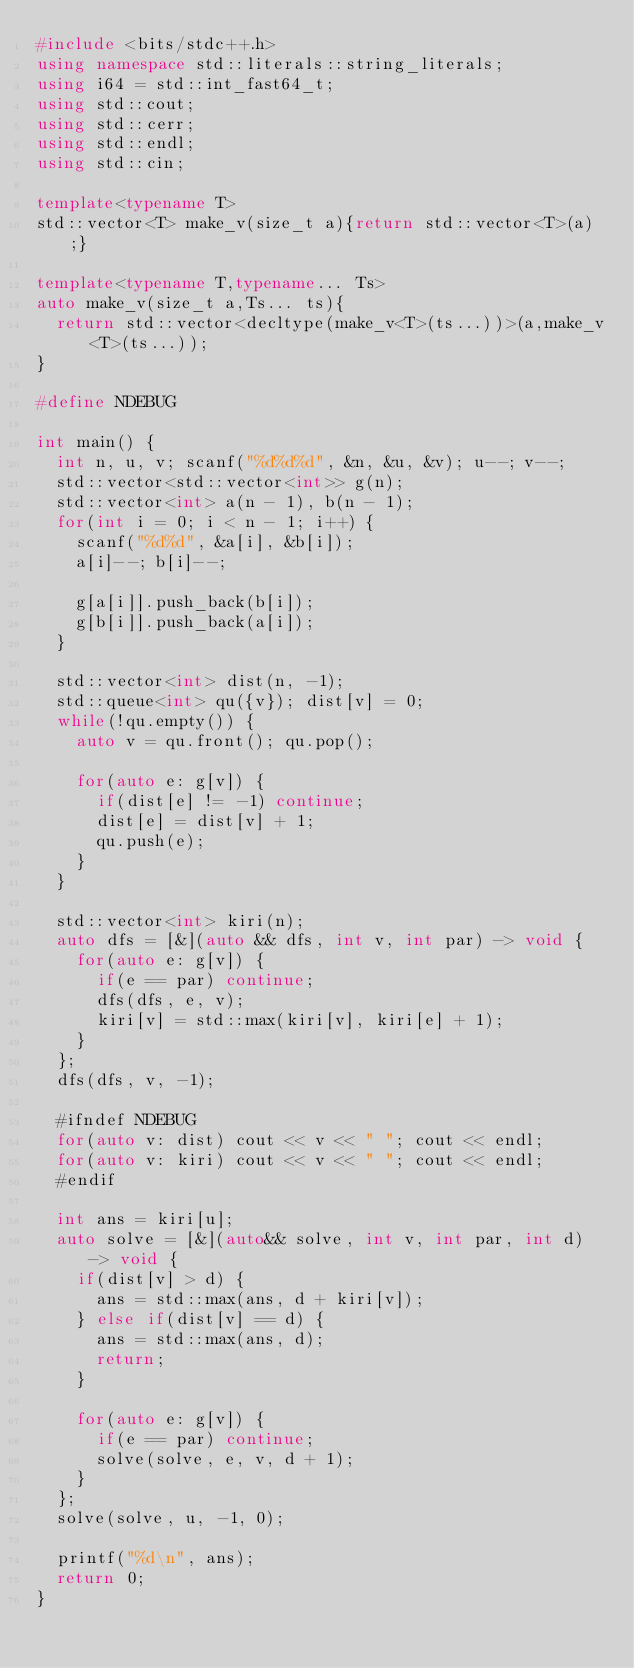Convert code to text. <code><loc_0><loc_0><loc_500><loc_500><_C++_>#include <bits/stdc++.h>
using namespace std::literals::string_literals;
using i64 = std::int_fast64_t;
using std::cout;
using std::cerr;
using std::endl;
using std::cin;

template<typename T>
std::vector<T> make_v(size_t a){return std::vector<T>(a);}

template<typename T,typename... Ts>
auto make_v(size_t a,Ts... ts){
  return std::vector<decltype(make_v<T>(ts...))>(a,make_v<T>(ts...));
}

#define NDEBUG

int main() {
	int n, u, v; scanf("%d%d%d", &n, &u, &v); u--; v--;
	std::vector<std::vector<int>> g(n);
	std::vector<int> a(n - 1), b(n - 1);
	for(int i = 0; i < n - 1; i++) {
		scanf("%d%d", &a[i], &b[i]);
		a[i]--; b[i]--;

		g[a[i]].push_back(b[i]);
		g[b[i]].push_back(a[i]);
	}

	std::vector<int> dist(n, -1);
	std::queue<int> qu({v}); dist[v] = 0;
	while(!qu.empty()) {
		auto v = qu.front(); qu.pop();

		for(auto e: g[v]) {
			if(dist[e] != -1) continue;
			dist[e] = dist[v] + 1;
			qu.push(e);
		}
	}
	
	std::vector<int> kiri(n);
	auto dfs = [&](auto && dfs, int v, int par) -> void {
		for(auto e: g[v]) {
			if(e == par) continue;
			dfs(dfs, e, v);
			kiri[v] = std::max(kiri[v], kiri[e] + 1);
		}
	};
	dfs(dfs, v, -1);

	#ifndef NDEBUG
	for(auto v: dist) cout << v << " "; cout << endl;
	for(auto v: kiri) cout << v << " "; cout << endl;
	#endif

	int ans = kiri[u];
	auto solve = [&](auto&& solve, int v, int par, int d) -> void {
		if(dist[v] > d) {
			ans = std::max(ans, d + kiri[v]);
		} else if(dist[v] == d) {
			ans = std::max(ans, d);
			return;
		}
		
		for(auto e: g[v]) {
			if(e == par) continue;
			solve(solve, e, v, d + 1);
		}
	};
	solve(solve, u, -1, 0);
	
	printf("%d\n", ans);
	return 0;
}
</code> 